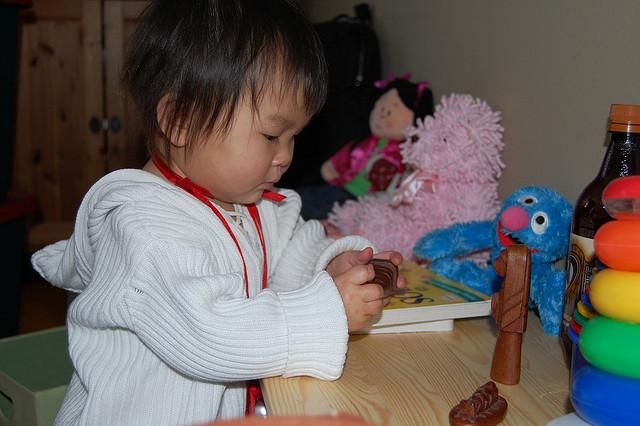What makes the bear scary?
Short answer required. Nothing. Is the baby in  a hospital?
Concise answer only. No. What is the bear dressed up as?
Be succinct. Bear. Is this a romantic evening?
Keep it brief. No. What color is the baby's hoodie?
Write a very short answer. White. What is the orange can of soda?
Give a very brief answer. Root beer. What famous Muppet is present?
Write a very short answer. Cookie monster. Why are there handles on these toys?
Concise answer only. To hold. What is the girl doing?
Short answer required. Playing. What color is her hair?
Give a very brief answer. Black. How do children play with these toys?
Be succinct. Hands. Is the baby eating?
Answer briefly. No. Is this a toy?
Concise answer only. Yes. How many dolls are there?
Be succinct. 1. What are the names of the stuffed animals in the high chair?
Answer briefly. Grover. How many stuffed animals are in the bin?
Be succinct. 3. Is it her birthday?
Write a very short answer. No. What is the child's race?
Short answer required. Asian. What color is the bear?
Write a very short answer. Pink. Did the toy belong to a boy?
Answer briefly. No. How many children are visible in this photo?
Quick response, please. 1. What is the color of the sweater?
Short answer required. White. What kind of stuffed animal is in the photo?
Concise answer only. Bear. How many dolls are in the image?
Keep it brief. 3. What is the primary color of her outfit?
Concise answer only. White. What is on the girls shirt?
Short answer required. Ribbon. What color is sweatshirt?
Write a very short answer. White. What is the teddy bear wearing?
Keep it brief. Bow. What song was being sung while this picture was taken?
Give a very brief answer. Not possible. What is the child holding?
Quick response, please. Toy. What ethnicity is the child?
Short answer required. Asian. Is there a clip in her hair?
Answer briefly. No. 